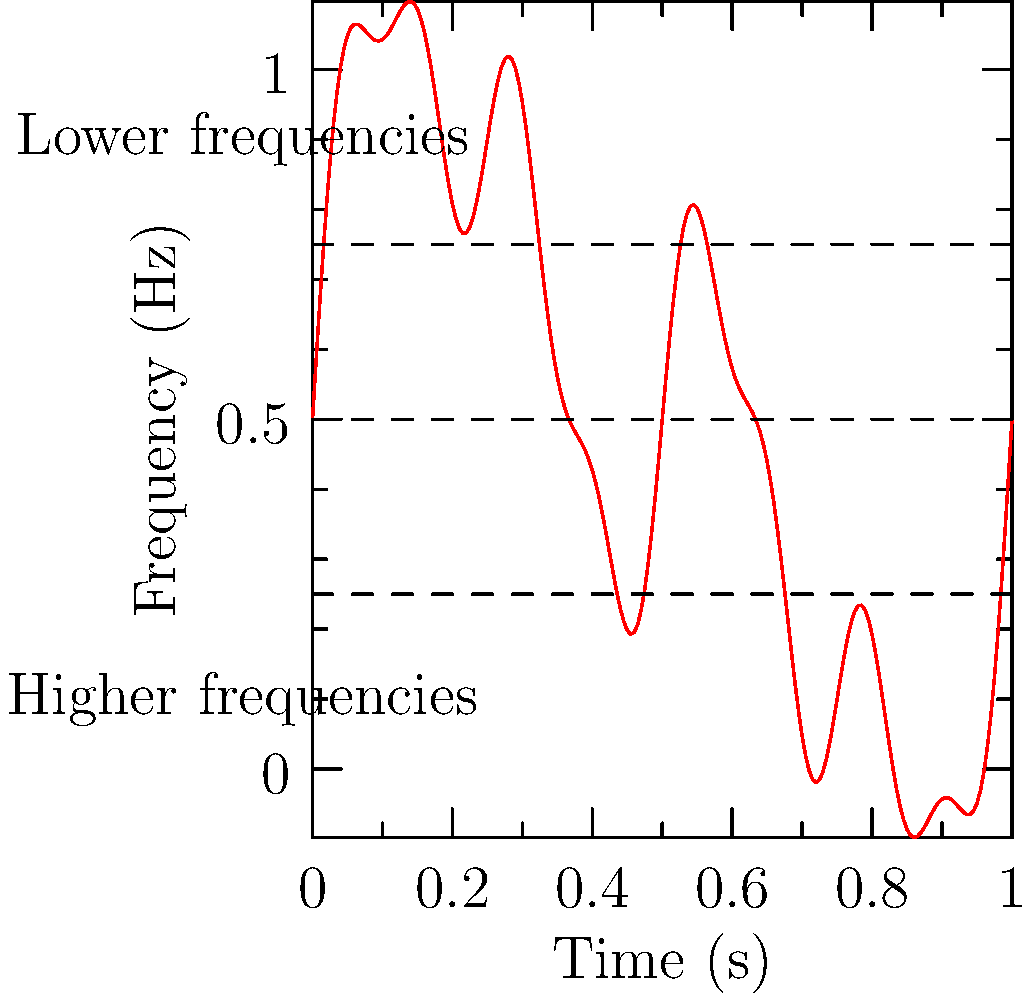In the spectrogram above representing a typical ska punk song, which frequency range shows the highest intensity, and what musical element does this likely correspond to? To answer this question, let's analyze the spectrogram step-by-step:

1. In a spectrogram, the vertical axis represents frequency, with lower frequencies at the bottom and higher frequencies at the top.

2. The intensity or amplitude of each frequency is represented by the brightness or color intensity of the graph. In this case, the red color indicates intensity.

3. Observing the graph, we can see that the most intense (brightest) red color appears in the lower half of the spectrogram, particularly in the bottom quarter.

4. This indicates that the highest intensity is in the lower frequency range.

5. In ska punk music, the lower frequency range typically corresponds to the rhythm section, particularly the bass guitar and the emphasized offbeat guitar chords.

6. The bass line and the "skank" guitar rhythm are crucial elements of ska punk, providing the characteristic upbeat, energetic feel of the genre.

7. These low-frequency elements are often prominently mixed in ska punk to drive the rhythm and provide the foundation for the horn section and vocals.

Therefore, the lower frequency range shows the highest intensity in this spectrogram, likely corresponding to the bass guitar and rhythm guitar parts that form the core of the ska punk sound.
Answer: Lower frequency range; bass and rhythm guitar 